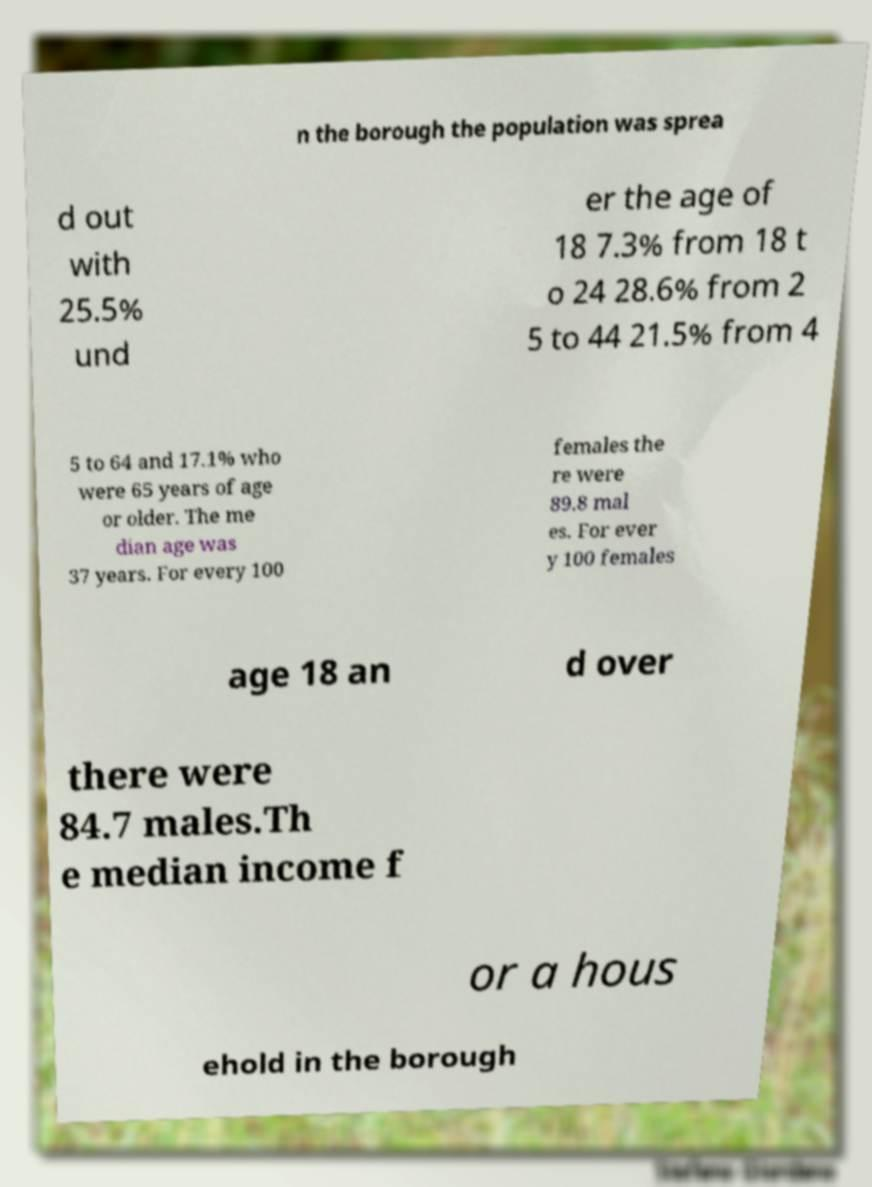Could you extract and type out the text from this image? n the borough the population was sprea d out with 25.5% und er the age of 18 7.3% from 18 t o 24 28.6% from 2 5 to 44 21.5% from 4 5 to 64 and 17.1% who were 65 years of age or older. The me dian age was 37 years. For every 100 females the re were 89.8 mal es. For ever y 100 females age 18 an d over there were 84.7 males.Th e median income f or a hous ehold in the borough 